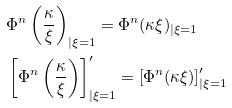Convert formula to latex. <formula><loc_0><loc_0><loc_500><loc_500>& \Phi ^ { n } \left ( \frac { \kappa } { \xi } \right ) _ { | \xi = 1 } = \Phi ^ { n } ( \kappa \xi ) _ { | \xi = 1 } \\ & \left [ \Phi ^ { n } \left ( \frac { \kappa } { \xi } \right ) \right ] ^ { \prime } _ { | \xi = 1 } = \left [ \Phi ^ { n } ( \kappa \xi ) \right ] ^ { \prime } _ { | \xi = 1 }</formula> 